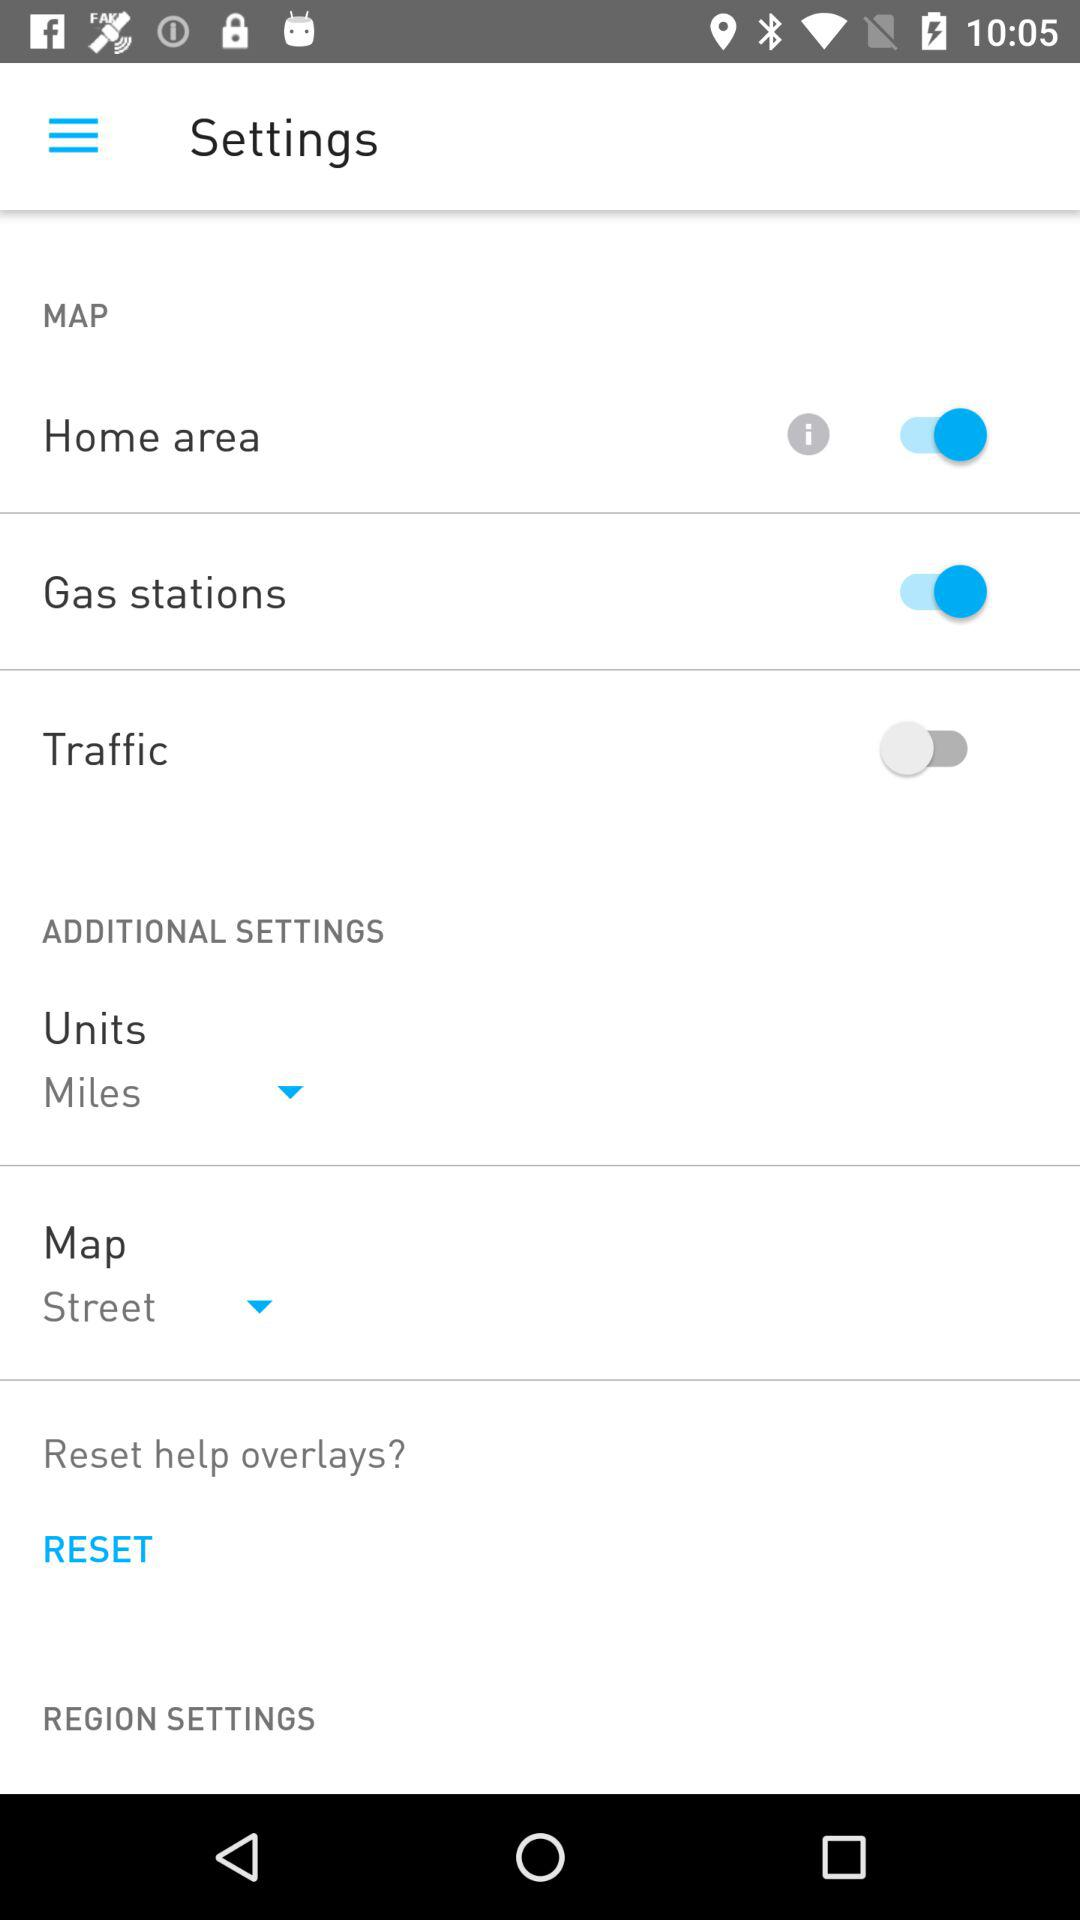How to reset help overlays?
When the provided information is insufficient, respond with <no answer>. <no answer> 